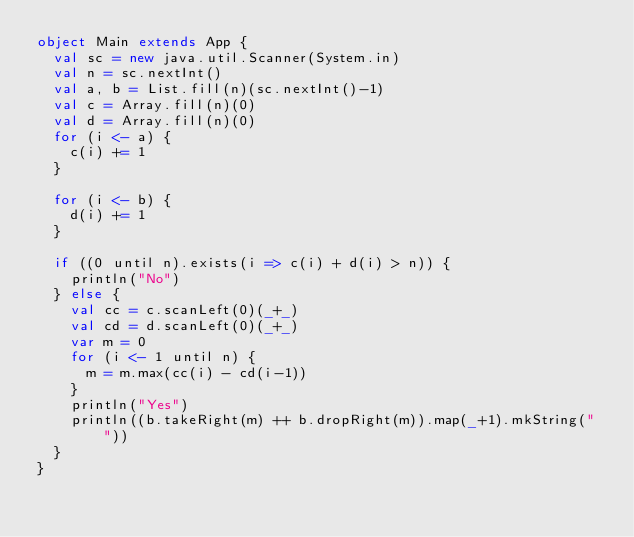Convert code to text. <code><loc_0><loc_0><loc_500><loc_500><_Scala_>object Main extends App {
  val sc = new java.util.Scanner(System.in)
  val n = sc.nextInt()
  val a, b = List.fill(n)(sc.nextInt()-1)
  val c = Array.fill(n)(0)
  val d = Array.fill(n)(0)
  for (i <- a) {
    c(i) += 1
  }

  for (i <- b) {
    d(i) += 1
  }

  if ((0 until n).exists(i => c(i) + d(i) > n)) {
    println("No")
  } else {
    val cc = c.scanLeft(0)(_+_)
    val cd = d.scanLeft(0)(_+_)
    var m = 0
    for (i <- 1 until n) {
      m = m.max(cc(i) - cd(i-1))
    }
    println("Yes")
    println((b.takeRight(m) ++ b.dropRight(m)).map(_+1).mkString(" "))
  }
}
</code> 